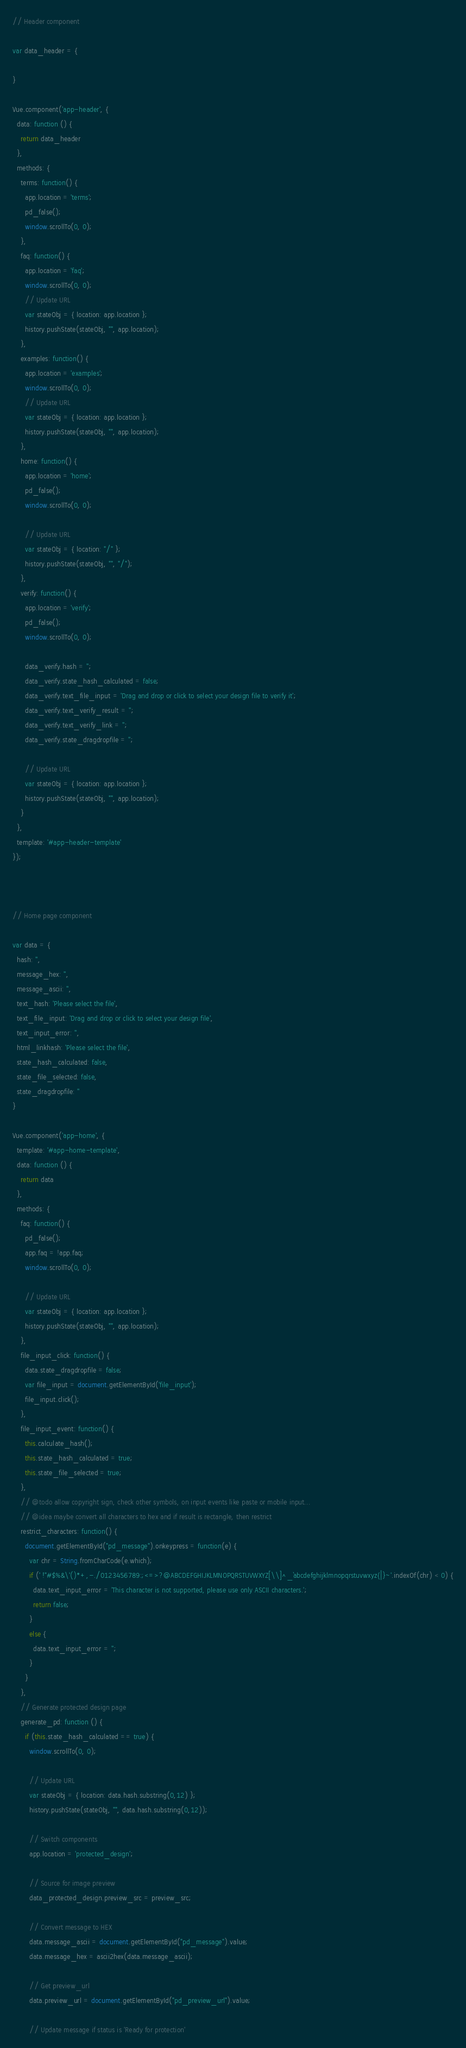Convert code to text. <code><loc_0><loc_0><loc_500><loc_500><_JavaScript_>// Header component

var data_header = {

}

Vue.component('app-header', {
  data: function () {
    return data_header
  },
  methods: {
    terms: function() {
      app.location = 'terms';
      pd_false();
      window.scrollTo(0, 0);
    },
    faq: function() {
      app.location = 'faq';
      window.scrollTo(0, 0);
      // Update URL
      var stateObj = { location: app.location };
      history.pushState(stateObj, "", app.location);
    },
    examples: function() {
      app.location = 'examples';
      window.scrollTo(0, 0);
      // Update URL
      var stateObj = { location: app.location };
      history.pushState(stateObj, "", app.location);
    },
    home: function() {
      app.location = 'home';
      pd_false();
      window.scrollTo(0, 0);

      // Update URL
      var stateObj = { location: "/" };
      history.pushState(stateObj, "", "/");
    },
    verify: function() {
      app.location = 'verify';
      pd_false();
      window.scrollTo(0, 0);
      
      data_verify.hash = '';
      data_verify.state_hash_calculated = false;
      data_verify.text_file_input = 'Drag and drop or click to select your design file to verify it';
      data_verify.text_verify_result = '';
      data_verify.text_verify_link = '';
      data_verify.state_dragdropfile = '';

      // Update URL
      var stateObj = { location: app.location };
      history.pushState(stateObj, "", app.location);
    }
  },
  template: '#app-header-template'
});



// Home page component

var data = {
  hash: '',
  message_hex: '',
  message_ascii: '',
  text_hash: 'Please select the file',
  text_file_input: 'Drag and drop or click to select your design file',
  text_input_error: '',
  html_linkhash: 'Please select the file',
  state_hash_calculated: false,
  state_file_selected: false,
  state_dragdropfile: ''
}

Vue.component('app-home', {
  template: '#app-home-template',
  data: function () {
    return data
  },
  methods: {
    faq: function() {
      pd_false();
      app.faq = !app.faq;
      window.scrollTo(0, 0);

      // Update URL
      var stateObj = { location: app.location };
      history.pushState(stateObj, "", app.location);
    },
    file_input_click: function() {
      data.state_dragdropfile = false;
      var file_input = document.getElementById('file_input');
      file_input.click();
    },
    file_input_event: function() {
      this.calculate_hash();
      this.state_hash_calculated = true;
      this.state_file_selected = true;
    },
    // @todo allow copyright sign, check other symbols, on input events like paste or mobile input...
    // @idea maybe convert all characters to hex and if result is rectangle, then restrict
    restrict_characters: function() {
      document.getElementById("pd_message").onkeypress = function(e) {
        var chr = String.fromCharCode(e.which);
        if (' !"#$%&\'()*+,-./0123456789:;<=>?@ABCDEFGHIJKLMNOPQRSTUVWXYZ[\\]^_`abcdefghijklmnopqrstuvwxyz{|}~'.indexOf(chr) < 0) {
          data.text_input_error = 'This character is not supported, please use only ASCII characters.';  
          return false;
        }
        else {
          data.text_input_error = '';
        }
      }
    },
    // Generate protected design page
    generate_pd: function () {
      if (this.state_hash_calculated == true) {
        window.scrollTo(0, 0);
        
        // Update URL
        var stateObj = { location: data.hash.substring(0,12) };
        history.pushState(stateObj, "", data.hash.substring(0,12));

        // Switch components
        app.location = 'protected_design';

        // Source for image preview
        data_protected_design.preview_src = preview_src;

        // Convert message to HEX
        data.message_ascii = document.getElementById("pd_message").value;
        data.message_hex = ascii2hex(data.message_ascii);

        // Get preview_url
        data.preview_url = document.getElementById("pd_preview_url").value;

        // Update message if status is 'Ready for protection'</code> 